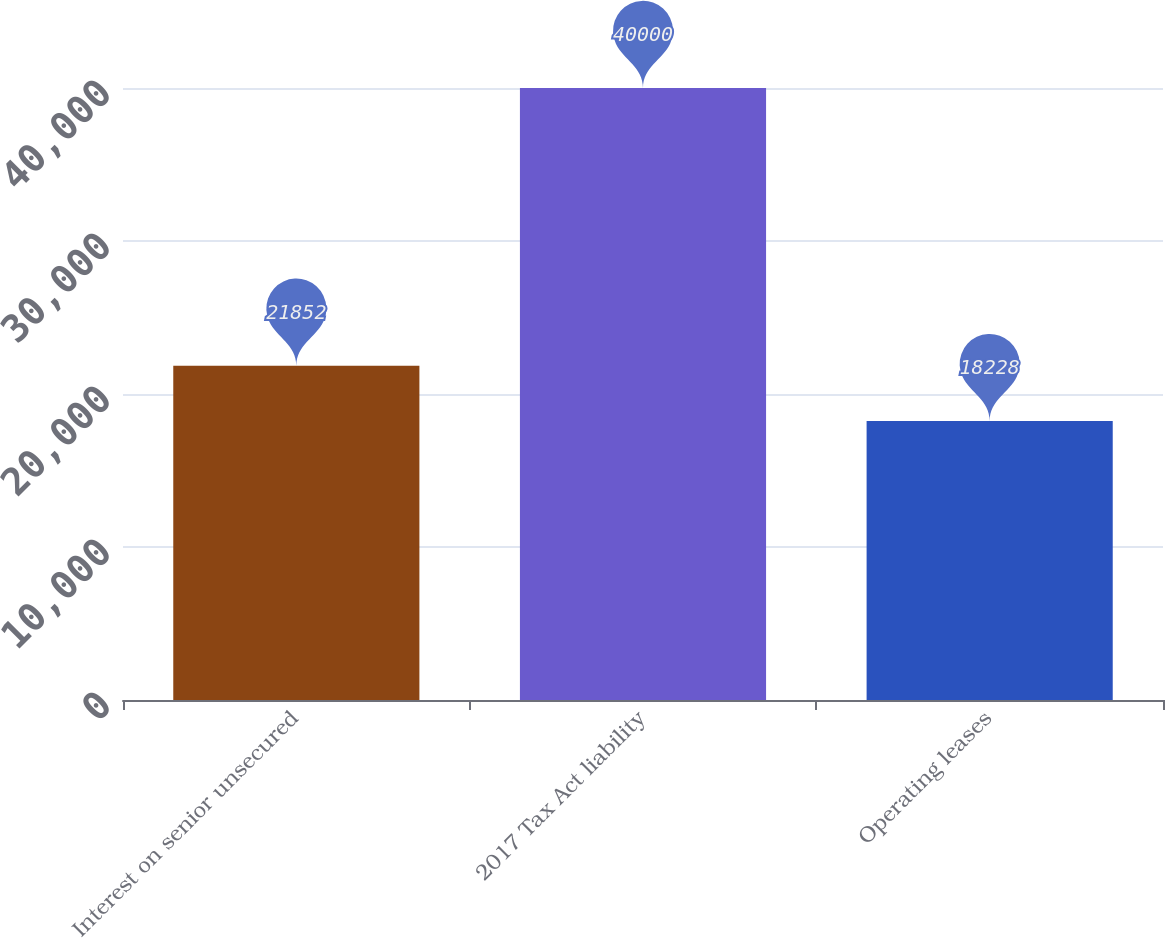<chart> <loc_0><loc_0><loc_500><loc_500><bar_chart><fcel>Interest on senior unsecured<fcel>2017 Tax Act liability<fcel>Operating leases<nl><fcel>21852<fcel>40000<fcel>18228<nl></chart> 